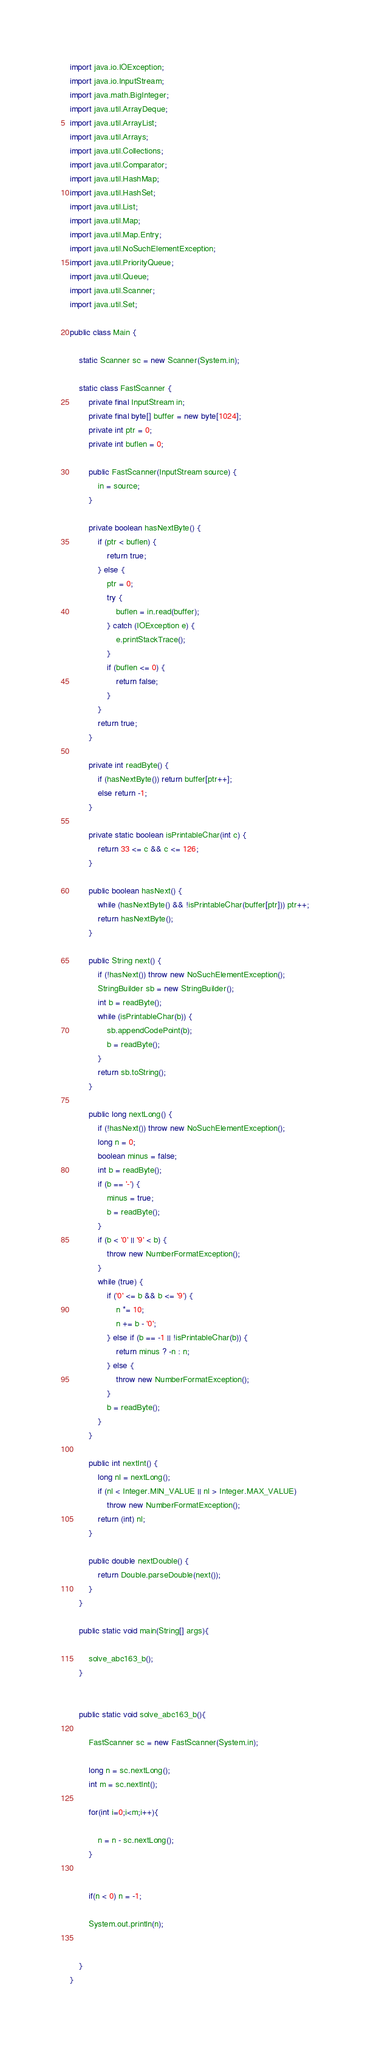<code> <loc_0><loc_0><loc_500><loc_500><_Java_>import java.io.IOException;
import java.io.InputStream;
import java.math.BigInteger;
import java.util.ArrayDeque;
import java.util.ArrayList;
import java.util.Arrays;
import java.util.Collections;
import java.util.Comparator;
import java.util.HashMap;
import java.util.HashSet;
import java.util.List;
import java.util.Map;
import java.util.Map.Entry;
import java.util.NoSuchElementException;
import java.util.PriorityQueue;
import java.util.Queue;
import java.util.Scanner;
import java.util.Set;

public class Main {

	static Scanner sc = new Scanner(System.in);

	static class FastScanner {
		private final InputStream in;
		private final byte[] buffer = new byte[1024];
		private int ptr = 0;
		private int buflen = 0;

		public FastScanner(InputStream source) {
			in = source;
		}

		private boolean hasNextByte() {
			if (ptr < buflen) {
				return true;
			} else {
				ptr = 0;
				try {
					buflen = in.read(buffer);
				} catch (IOException e) {
					e.printStackTrace();
				}
				if (buflen <= 0) {
					return false;
				}
			}
			return true;
		}

		private int readByte() {
			if (hasNextByte()) return buffer[ptr++];
			else return -1;
		}

		private static boolean isPrintableChar(int c) {
			return 33 <= c && c <= 126;
		}

		public boolean hasNext() {
			while (hasNextByte() && !isPrintableChar(buffer[ptr])) ptr++;
			return hasNextByte();
		}

		public String next() {
			if (!hasNext()) throw new NoSuchElementException();
			StringBuilder sb = new StringBuilder();
			int b = readByte();
			while (isPrintableChar(b)) {
				sb.appendCodePoint(b);
				b = readByte();
			}
			return sb.toString();
		}

		public long nextLong() {
			if (!hasNext()) throw new NoSuchElementException();
			long n = 0;
			boolean minus = false;
			int b = readByte();
			if (b == '-') {
				minus = true;
				b = readByte();
			}
			if (b < '0' || '9' < b) {
				throw new NumberFormatException();
			}
			while (true) {
				if ('0' <= b && b <= '9') {
					n *= 10;
					n += b - '0';
				} else if (b == -1 || !isPrintableChar(b)) {
					return minus ? -n : n;
				} else {
					throw new NumberFormatException();
				}
				b = readByte();
			}
		}

		public int nextInt() {
			long nl = nextLong();
			if (nl < Integer.MIN_VALUE || nl > Integer.MAX_VALUE)
				throw new NumberFormatException();
			return (int) nl;
		}

		public double nextDouble() {
			return Double.parseDouble(next());
		}
	}

	public static void main(String[] args){

		solve_abc163_b();
	}
  
  
	public static void solve_abc163_b(){

		FastScanner sc = new FastScanner(System.in);
		
		long n = sc.nextLong();
		int m = sc.nextInt();
		
		for(int i=0;i<m;i++){
			
			n = n - sc.nextLong();
		}
		
		
		if(n < 0) n = -1;
		
		System.out.println(n);


	}
}</code> 